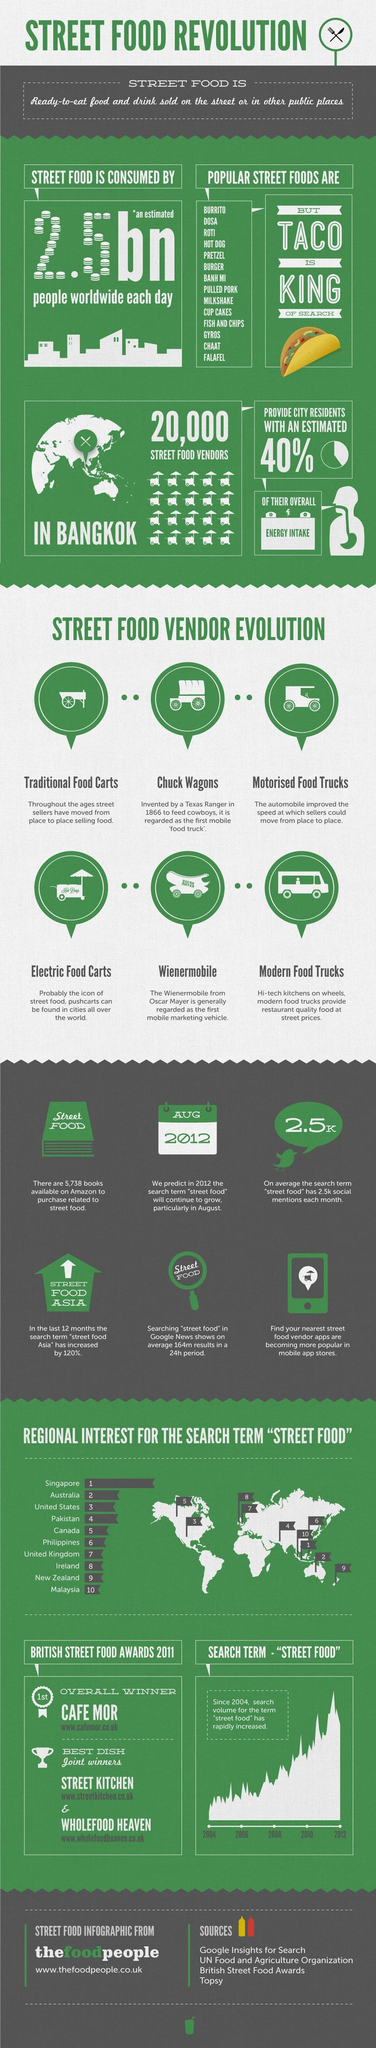Indicate a few pertinent items in this graphic. The search term "street food" increased in the year 2012. 